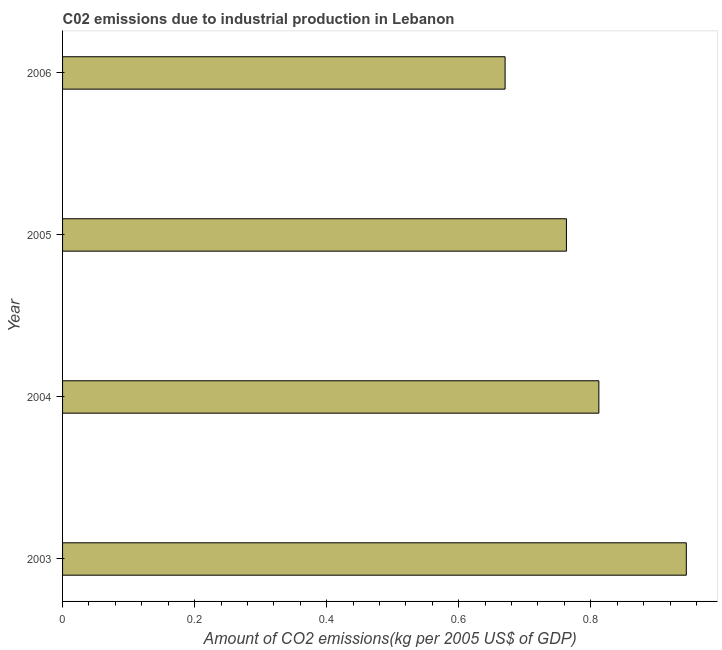Does the graph contain any zero values?
Your answer should be compact. No. What is the title of the graph?
Offer a terse response. C02 emissions due to industrial production in Lebanon. What is the label or title of the X-axis?
Offer a very short reply. Amount of CO2 emissions(kg per 2005 US$ of GDP). What is the amount of co2 emissions in 2003?
Your answer should be very brief. 0.94. Across all years, what is the maximum amount of co2 emissions?
Your answer should be very brief. 0.94. Across all years, what is the minimum amount of co2 emissions?
Keep it short and to the point. 0.67. In which year was the amount of co2 emissions maximum?
Offer a terse response. 2003. In which year was the amount of co2 emissions minimum?
Provide a short and direct response. 2006. What is the sum of the amount of co2 emissions?
Your answer should be very brief. 3.19. What is the difference between the amount of co2 emissions in 2003 and 2005?
Your answer should be compact. 0.18. What is the average amount of co2 emissions per year?
Keep it short and to the point. 0.8. What is the median amount of co2 emissions?
Your answer should be compact. 0.79. What is the ratio of the amount of co2 emissions in 2004 to that in 2006?
Provide a short and direct response. 1.21. What is the difference between the highest and the second highest amount of co2 emissions?
Offer a very short reply. 0.13. What is the difference between the highest and the lowest amount of co2 emissions?
Offer a terse response. 0.27. How many bars are there?
Offer a very short reply. 4. How many years are there in the graph?
Your response must be concise. 4. What is the Amount of CO2 emissions(kg per 2005 US$ of GDP) in 2003?
Your answer should be very brief. 0.94. What is the Amount of CO2 emissions(kg per 2005 US$ of GDP) of 2004?
Your response must be concise. 0.81. What is the Amount of CO2 emissions(kg per 2005 US$ of GDP) of 2005?
Keep it short and to the point. 0.76. What is the Amount of CO2 emissions(kg per 2005 US$ of GDP) of 2006?
Provide a succinct answer. 0.67. What is the difference between the Amount of CO2 emissions(kg per 2005 US$ of GDP) in 2003 and 2004?
Provide a short and direct response. 0.13. What is the difference between the Amount of CO2 emissions(kg per 2005 US$ of GDP) in 2003 and 2005?
Your response must be concise. 0.18. What is the difference between the Amount of CO2 emissions(kg per 2005 US$ of GDP) in 2003 and 2006?
Your answer should be compact. 0.27. What is the difference between the Amount of CO2 emissions(kg per 2005 US$ of GDP) in 2004 and 2005?
Your response must be concise. 0.05. What is the difference between the Amount of CO2 emissions(kg per 2005 US$ of GDP) in 2004 and 2006?
Your answer should be very brief. 0.14. What is the difference between the Amount of CO2 emissions(kg per 2005 US$ of GDP) in 2005 and 2006?
Make the answer very short. 0.09. What is the ratio of the Amount of CO2 emissions(kg per 2005 US$ of GDP) in 2003 to that in 2004?
Your answer should be very brief. 1.16. What is the ratio of the Amount of CO2 emissions(kg per 2005 US$ of GDP) in 2003 to that in 2005?
Provide a succinct answer. 1.24. What is the ratio of the Amount of CO2 emissions(kg per 2005 US$ of GDP) in 2003 to that in 2006?
Your response must be concise. 1.41. What is the ratio of the Amount of CO2 emissions(kg per 2005 US$ of GDP) in 2004 to that in 2005?
Keep it short and to the point. 1.06. What is the ratio of the Amount of CO2 emissions(kg per 2005 US$ of GDP) in 2004 to that in 2006?
Your response must be concise. 1.21. What is the ratio of the Amount of CO2 emissions(kg per 2005 US$ of GDP) in 2005 to that in 2006?
Give a very brief answer. 1.14. 